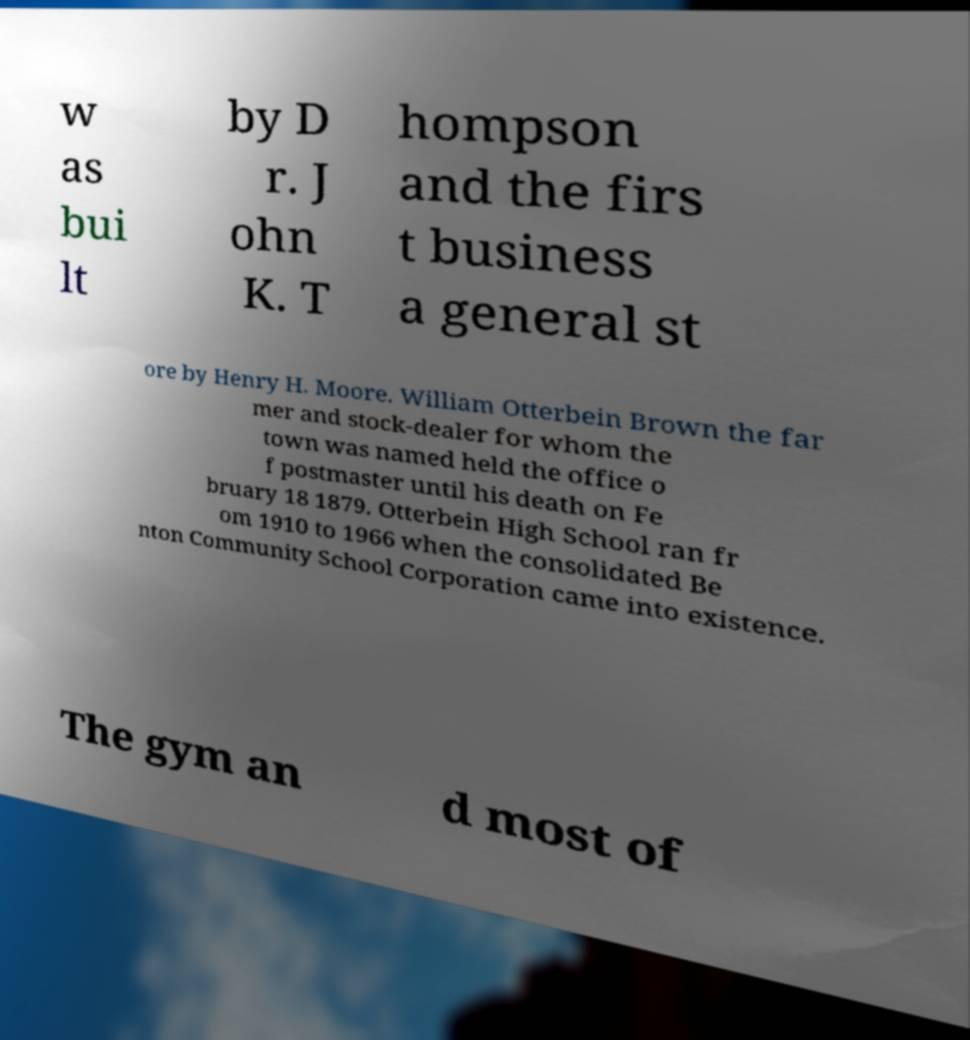Could you extract and type out the text from this image? w as bui lt by D r. J ohn K. T hompson and the firs t business a general st ore by Henry H. Moore. William Otterbein Brown the far mer and stock-dealer for whom the town was named held the office o f postmaster until his death on Fe bruary 18 1879. Otterbein High School ran fr om 1910 to 1966 when the consolidated Be nton Community School Corporation came into existence. The gym an d most of 